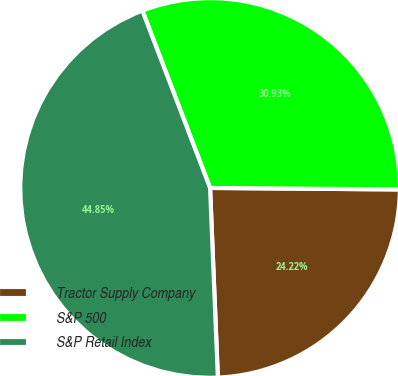<chart> <loc_0><loc_0><loc_500><loc_500><pie_chart><fcel>Tractor Supply Company<fcel>S&P 500<fcel>S&P Retail Index<nl><fcel>24.22%<fcel>30.93%<fcel>44.85%<nl></chart> 